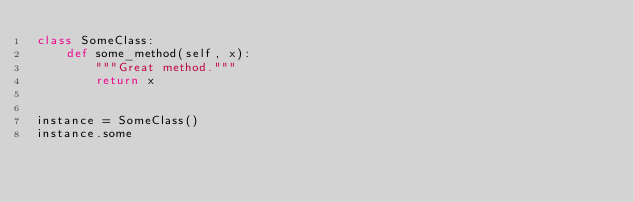<code> <loc_0><loc_0><loc_500><loc_500><_Python_>class SomeClass:
    def some_method(self, x):
        """Great method."""
        return x


instance = SomeClass()
instance.some
</code> 